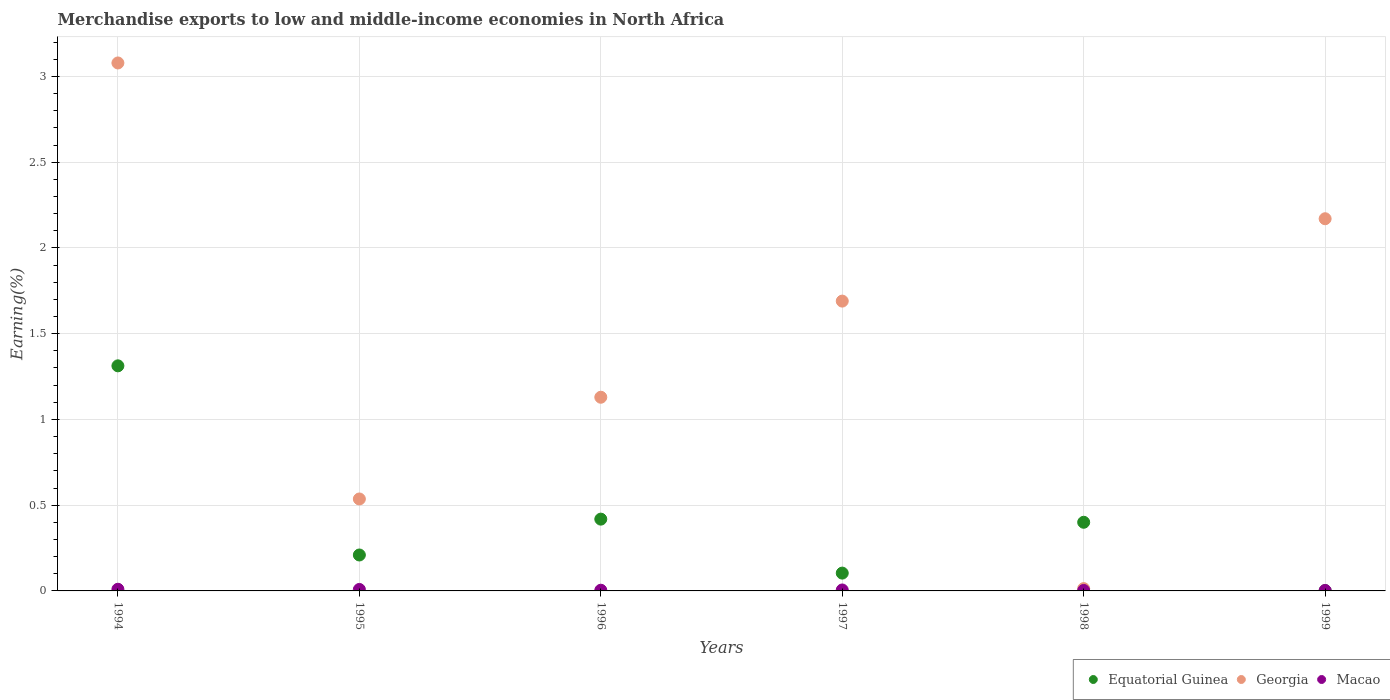How many different coloured dotlines are there?
Offer a terse response. 3. What is the percentage of amount earned from merchandise exports in Equatorial Guinea in 1996?
Offer a very short reply. 0.42. Across all years, what is the maximum percentage of amount earned from merchandise exports in Georgia?
Your response must be concise. 3.08. Across all years, what is the minimum percentage of amount earned from merchandise exports in Equatorial Guinea?
Ensure brevity in your answer.  0. In which year was the percentage of amount earned from merchandise exports in Georgia maximum?
Offer a very short reply. 1994. What is the total percentage of amount earned from merchandise exports in Equatorial Guinea in the graph?
Your answer should be compact. 2.45. What is the difference between the percentage of amount earned from merchandise exports in Equatorial Guinea in 1996 and that in 1998?
Offer a terse response. 0.02. What is the difference between the percentage of amount earned from merchandise exports in Equatorial Guinea in 1997 and the percentage of amount earned from merchandise exports in Georgia in 1995?
Your answer should be very brief. -0.43. What is the average percentage of amount earned from merchandise exports in Georgia per year?
Offer a terse response. 1.44. In the year 1995, what is the difference between the percentage of amount earned from merchandise exports in Macao and percentage of amount earned from merchandise exports in Georgia?
Provide a short and direct response. -0.53. What is the ratio of the percentage of amount earned from merchandise exports in Equatorial Guinea in 1997 to that in 1998?
Make the answer very short. 0.26. What is the difference between the highest and the second highest percentage of amount earned from merchandise exports in Equatorial Guinea?
Give a very brief answer. 0.89. What is the difference between the highest and the lowest percentage of amount earned from merchandise exports in Equatorial Guinea?
Offer a terse response. 1.31. In how many years, is the percentage of amount earned from merchandise exports in Macao greater than the average percentage of amount earned from merchandise exports in Macao taken over all years?
Provide a succinct answer. 2. Is the sum of the percentage of amount earned from merchandise exports in Georgia in 1994 and 1997 greater than the maximum percentage of amount earned from merchandise exports in Equatorial Guinea across all years?
Give a very brief answer. Yes. Is it the case that in every year, the sum of the percentage of amount earned from merchandise exports in Equatorial Guinea and percentage of amount earned from merchandise exports in Georgia  is greater than the percentage of amount earned from merchandise exports in Macao?
Offer a very short reply. Yes. How many dotlines are there?
Ensure brevity in your answer.  3. What is the difference between two consecutive major ticks on the Y-axis?
Your response must be concise. 0.5. Are the values on the major ticks of Y-axis written in scientific E-notation?
Your answer should be compact. No. Does the graph contain grids?
Your response must be concise. Yes. How many legend labels are there?
Give a very brief answer. 3. What is the title of the graph?
Your answer should be very brief. Merchandise exports to low and middle-income economies in North Africa. Does "United States" appear as one of the legend labels in the graph?
Give a very brief answer. No. What is the label or title of the Y-axis?
Your answer should be compact. Earning(%). What is the Earning(%) of Equatorial Guinea in 1994?
Give a very brief answer. 1.31. What is the Earning(%) in Georgia in 1994?
Provide a short and direct response. 3.08. What is the Earning(%) of Macao in 1994?
Your response must be concise. 0.01. What is the Earning(%) in Equatorial Guinea in 1995?
Offer a very short reply. 0.21. What is the Earning(%) in Georgia in 1995?
Offer a very short reply. 0.54. What is the Earning(%) in Macao in 1995?
Provide a short and direct response. 0.01. What is the Earning(%) in Equatorial Guinea in 1996?
Keep it short and to the point. 0.42. What is the Earning(%) in Georgia in 1996?
Offer a terse response. 1.13. What is the Earning(%) in Macao in 1996?
Keep it short and to the point. 0. What is the Earning(%) in Equatorial Guinea in 1997?
Ensure brevity in your answer.  0.1. What is the Earning(%) in Georgia in 1997?
Make the answer very short. 1.69. What is the Earning(%) in Macao in 1997?
Ensure brevity in your answer.  0.01. What is the Earning(%) in Equatorial Guinea in 1998?
Ensure brevity in your answer.  0.4. What is the Earning(%) in Georgia in 1998?
Your response must be concise. 0.01. What is the Earning(%) in Macao in 1998?
Your response must be concise. 0. What is the Earning(%) in Equatorial Guinea in 1999?
Give a very brief answer. 0. What is the Earning(%) in Georgia in 1999?
Your answer should be compact. 2.17. What is the Earning(%) of Macao in 1999?
Your answer should be very brief. 0. Across all years, what is the maximum Earning(%) in Equatorial Guinea?
Give a very brief answer. 1.31. Across all years, what is the maximum Earning(%) of Georgia?
Make the answer very short. 3.08. Across all years, what is the maximum Earning(%) in Macao?
Your response must be concise. 0.01. Across all years, what is the minimum Earning(%) of Equatorial Guinea?
Make the answer very short. 0. Across all years, what is the minimum Earning(%) of Georgia?
Provide a succinct answer. 0.01. Across all years, what is the minimum Earning(%) in Macao?
Offer a terse response. 0. What is the total Earning(%) in Equatorial Guinea in the graph?
Offer a very short reply. 2.45. What is the total Earning(%) of Georgia in the graph?
Ensure brevity in your answer.  8.62. What is the total Earning(%) of Macao in the graph?
Ensure brevity in your answer.  0.03. What is the difference between the Earning(%) of Equatorial Guinea in 1994 and that in 1995?
Your answer should be compact. 1.1. What is the difference between the Earning(%) in Georgia in 1994 and that in 1995?
Offer a terse response. 2.54. What is the difference between the Earning(%) of Macao in 1994 and that in 1995?
Your answer should be compact. 0. What is the difference between the Earning(%) in Equatorial Guinea in 1994 and that in 1996?
Ensure brevity in your answer.  0.89. What is the difference between the Earning(%) in Georgia in 1994 and that in 1996?
Provide a short and direct response. 1.95. What is the difference between the Earning(%) of Macao in 1994 and that in 1996?
Your answer should be very brief. 0.01. What is the difference between the Earning(%) of Equatorial Guinea in 1994 and that in 1997?
Give a very brief answer. 1.21. What is the difference between the Earning(%) of Georgia in 1994 and that in 1997?
Make the answer very short. 1.39. What is the difference between the Earning(%) in Macao in 1994 and that in 1997?
Your answer should be compact. 0. What is the difference between the Earning(%) of Equatorial Guinea in 1994 and that in 1998?
Your response must be concise. 0.91. What is the difference between the Earning(%) of Georgia in 1994 and that in 1998?
Ensure brevity in your answer.  3.07. What is the difference between the Earning(%) in Macao in 1994 and that in 1998?
Offer a terse response. 0.01. What is the difference between the Earning(%) in Equatorial Guinea in 1994 and that in 1999?
Your response must be concise. 1.31. What is the difference between the Earning(%) of Georgia in 1994 and that in 1999?
Your answer should be very brief. 0.91. What is the difference between the Earning(%) in Macao in 1994 and that in 1999?
Give a very brief answer. 0.01. What is the difference between the Earning(%) of Equatorial Guinea in 1995 and that in 1996?
Keep it short and to the point. -0.21. What is the difference between the Earning(%) in Georgia in 1995 and that in 1996?
Ensure brevity in your answer.  -0.59. What is the difference between the Earning(%) of Macao in 1995 and that in 1996?
Your answer should be very brief. 0. What is the difference between the Earning(%) of Equatorial Guinea in 1995 and that in 1997?
Make the answer very short. 0.11. What is the difference between the Earning(%) of Georgia in 1995 and that in 1997?
Offer a terse response. -1.15. What is the difference between the Earning(%) of Macao in 1995 and that in 1997?
Your response must be concise. 0. What is the difference between the Earning(%) of Equatorial Guinea in 1995 and that in 1998?
Keep it short and to the point. -0.19. What is the difference between the Earning(%) in Georgia in 1995 and that in 1998?
Ensure brevity in your answer.  0.52. What is the difference between the Earning(%) in Macao in 1995 and that in 1998?
Offer a terse response. 0.01. What is the difference between the Earning(%) of Equatorial Guinea in 1995 and that in 1999?
Keep it short and to the point. 0.21. What is the difference between the Earning(%) of Georgia in 1995 and that in 1999?
Offer a terse response. -1.63. What is the difference between the Earning(%) of Macao in 1995 and that in 1999?
Offer a terse response. 0.01. What is the difference between the Earning(%) in Equatorial Guinea in 1996 and that in 1997?
Your answer should be compact. 0.31. What is the difference between the Earning(%) of Georgia in 1996 and that in 1997?
Your answer should be compact. -0.56. What is the difference between the Earning(%) of Macao in 1996 and that in 1997?
Your answer should be very brief. -0. What is the difference between the Earning(%) in Equatorial Guinea in 1996 and that in 1998?
Provide a succinct answer. 0.02. What is the difference between the Earning(%) of Georgia in 1996 and that in 1998?
Ensure brevity in your answer.  1.12. What is the difference between the Earning(%) in Macao in 1996 and that in 1998?
Ensure brevity in your answer.  0. What is the difference between the Earning(%) of Equatorial Guinea in 1996 and that in 1999?
Ensure brevity in your answer.  0.42. What is the difference between the Earning(%) of Georgia in 1996 and that in 1999?
Your answer should be very brief. -1.04. What is the difference between the Earning(%) of Macao in 1996 and that in 1999?
Your answer should be compact. 0. What is the difference between the Earning(%) in Equatorial Guinea in 1997 and that in 1998?
Offer a terse response. -0.3. What is the difference between the Earning(%) in Georgia in 1997 and that in 1998?
Your answer should be very brief. 1.68. What is the difference between the Earning(%) in Macao in 1997 and that in 1998?
Ensure brevity in your answer.  0. What is the difference between the Earning(%) of Equatorial Guinea in 1997 and that in 1999?
Provide a succinct answer. 0.1. What is the difference between the Earning(%) of Georgia in 1997 and that in 1999?
Your answer should be compact. -0.48. What is the difference between the Earning(%) of Macao in 1997 and that in 1999?
Make the answer very short. 0. What is the difference between the Earning(%) of Equatorial Guinea in 1998 and that in 1999?
Provide a short and direct response. 0.4. What is the difference between the Earning(%) in Georgia in 1998 and that in 1999?
Keep it short and to the point. -2.16. What is the difference between the Earning(%) in Equatorial Guinea in 1994 and the Earning(%) in Georgia in 1995?
Make the answer very short. 0.78. What is the difference between the Earning(%) in Equatorial Guinea in 1994 and the Earning(%) in Macao in 1995?
Keep it short and to the point. 1.3. What is the difference between the Earning(%) of Georgia in 1994 and the Earning(%) of Macao in 1995?
Your answer should be very brief. 3.07. What is the difference between the Earning(%) in Equatorial Guinea in 1994 and the Earning(%) in Georgia in 1996?
Provide a short and direct response. 0.18. What is the difference between the Earning(%) in Equatorial Guinea in 1994 and the Earning(%) in Macao in 1996?
Offer a very short reply. 1.31. What is the difference between the Earning(%) in Georgia in 1994 and the Earning(%) in Macao in 1996?
Give a very brief answer. 3.07. What is the difference between the Earning(%) of Equatorial Guinea in 1994 and the Earning(%) of Georgia in 1997?
Provide a short and direct response. -0.38. What is the difference between the Earning(%) of Equatorial Guinea in 1994 and the Earning(%) of Macao in 1997?
Offer a terse response. 1.31. What is the difference between the Earning(%) in Georgia in 1994 and the Earning(%) in Macao in 1997?
Provide a short and direct response. 3.07. What is the difference between the Earning(%) in Equatorial Guinea in 1994 and the Earning(%) in Georgia in 1998?
Keep it short and to the point. 1.3. What is the difference between the Earning(%) in Equatorial Guinea in 1994 and the Earning(%) in Macao in 1998?
Give a very brief answer. 1.31. What is the difference between the Earning(%) in Georgia in 1994 and the Earning(%) in Macao in 1998?
Keep it short and to the point. 3.08. What is the difference between the Earning(%) of Equatorial Guinea in 1994 and the Earning(%) of Georgia in 1999?
Provide a short and direct response. -0.86. What is the difference between the Earning(%) in Equatorial Guinea in 1994 and the Earning(%) in Macao in 1999?
Keep it short and to the point. 1.31. What is the difference between the Earning(%) of Georgia in 1994 and the Earning(%) of Macao in 1999?
Give a very brief answer. 3.08. What is the difference between the Earning(%) of Equatorial Guinea in 1995 and the Earning(%) of Georgia in 1996?
Ensure brevity in your answer.  -0.92. What is the difference between the Earning(%) of Equatorial Guinea in 1995 and the Earning(%) of Macao in 1996?
Your response must be concise. 0.21. What is the difference between the Earning(%) in Georgia in 1995 and the Earning(%) in Macao in 1996?
Your answer should be compact. 0.53. What is the difference between the Earning(%) in Equatorial Guinea in 1995 and the Earning(%) in Georgia in 1997?
Make the answer very short. -1.48. What is the difference between the Earning(%) in Equatorial Guinea in 1995 and the Earning(%) in Macao in 1997?
Give a very brief answer. 0.2. What is the difference between the Earning(%) of Georgia in 1995 and the Earning(%) of Macao in 1997?
Offer a terse response. 0.53. What is the difference between the Earning(%) in Equatorial Guinea in 1995 and the Earning(%) in Georgia in 1998?
Ensure brevity in your answer.  0.2. What is the difference between the Earning(%) in Equatorial Guinea in 1995 and the Earning(%) in Macao in 1998?
Your answer should be compact. 0.21. What is the difference between the Earning(%) of Georgia in 1995 and the Earning(%) of Macao in 1998?
Your response must be concise. 0.53. What is the difference between the Earning(%) of Equatorial Guinea in 1995 and the Earning(%) of Georgia in 1999?
Provide a short and direct response. -1.96. What is the difference between the Earning(%) of Equatorial Guinea in 1995 and the Earning(%) of Macao in 1999?
Your answer should be compact. 0.21. What is the difference between the Earning(%) of Georgia in 1995 and the Earning(%) of Macao in 1999?
Offer a very short reply. 0.53. What is the difference between the Earning(%) of Equatorial Guinea in 1996 and the Earning(%) of Georgia in 1997?
Keep it short and to the point. -1.27. What is the difference between the Earning(%) in Equatorial Guinea in 1996 and the Earning(%) in Macao in 1997?
Keep it short and to the point. 0.41. What is the difference between the Earning(%) in Georgia in 1996 and the Earning(%) in Macao in 1997?
Offer a very short reply. 1.12. What is the difference between the Earning(%) in Equatorial Guinea in 1996 and the Earning(%) in Georgia in 1998?
Provide a short and direct response. 0.41. What is the difference between the Earning(%) of Equatorial Guinea in 1996 and the Earning(%) of Macao in 1998?
Ensure brevity in your answer.  0.42. What is the difference between the Earning(%) of Georgia in 1996 and the Earning(%) of Macao in 1998?
Make the answer very short. 1.13. What is the difference between the Earning(%) in Equatorial Guinea in 1996 and the Earning(%) in Georgia in 1999?
Offer a terse response. -1.75. What is the difference between the Earning(%) in Equatorial Guinea in 1996 and the Earning(%) in Macao in 1999?
Offer a very short reply. 0.42. What is the difference between the Earning(%) of Georgia in 1996 and the Earning(%) of Macao in 1999?
Offer a terse response. 1.13. What is the difference between the Earning(%) of Equatorial Guinea in 1997 and the Earning(%) of Georgia in 1998?
Make the answer very short. 0.09. What is the difference between the Earning(%) in Equatorial Guinea in 1997 and the Earning(%) in Macao in 1998?
Your answer should be very brief. 0.1. What is the difference between the Earning(%) in Georgia in 1997 and the Earning(%) in Macao in 1998?
Provide a succinct answer. 1.69. What is the difference between the Earning(%) of Equatorial Guinea in 1997 and the Earning(%) of Georgia in 1999?
Your response must be concise. -2.07. What is the difference between the Earning(%) of Equatorial Guinea in 1997 and the Earning(%) of Macao in 1999?
Your answer should be compact. 0.1. What is the difference between the Earning(%) of Georgia in 1997 and the Earning(%) of Macao in 1999?
Keep it short and to the point. 1.69. What is the difference between the Earning(%) of Equatorial Guinea in 1998 and the Earning(%) of Georgia in 1999?
Your response must be concise. -1.77. What is the difference between the Earning(%) of Equatorial Guinea in 1998 and the Earning(%) of Macao in 1999?
Make the answer very short. 0.4. What is the difference between the Earning(%) of Georgia in 1998 and the Earning(%) of Macao in 1999?
Offer a very short reply. 0.01. What is the average Earning(%) in Equatorial Guinea per year?
Give a very brief answer. 0.41. What is the average Earning(%) of Georgia per year?
Your answer should be very brief. 1.44. What is the average Earning(%) in Macao per year?
Provide a short and direct response. 0.01. In the year 1994, what is the difference between the Earning(%) in Equatorial Guinea and Earning(%) in Georgia?
Your answer should be very brief. -1.77. In the year 1994, what is the difference between the Earning(%) in Equatorial Guinea and Earning(%) in Macao?
Keep it short and to the point. 1.3. In the year 1994, what is the difference between the Earning(%) in Georgia and Earning(%) in Macao?
Your answer should be compact. 3.07. In the year 1995, what is the difference between the Earning(%) of Equatorial Guinea and Earning(%) of Georgia?
Provide a short and direct response. -0.33. In the year 1995, what is the difference between the Earning(%) in Equatorial Guinea and Earning(%) in Macao?
Your answer should be very brief. 0.2. In the year 1995, what is the difference between the Earning(%) in Georgia and Earning(%) in Macao?
Make the answer very short. 0.53. In the year 1996, what is the difference between the Earning(%) in Equatorial Guinea and Earning(%) in Georgia?
Ensure brevity in your answer.  -0.71. In the year 1996, what is the difference between the Earning(%) of Equatorial Guinea and Earning(%) of Macao?
Provide a succinct answer. 0.41. In the year 1996, what is the difference between the Earning(%) in Georgia and Earning(%) in Macao?
Your response must be concise. 1.13. In the year 1997, what is the difference between the Earning(%) in Equatorial Guinea and Earning(%) in Georgia?
Your answer should be compact. -1.59. In the year 1997, what is the difference between the Earning(%) in Equatorial Guinea and Earning(%) in Macao?
Your answer should be compact. 0.1. In the year 1997, what is the difference between the Earning(%) in Georgia and Earning(%) in Macao?
Give a very brief answer. 1.68. In the year 1998, what is the difference between the Earning(%) in Equatorial Guinea and Earning(%) in Georgia?
Your answer should be very brief. 0.39. In the year 1998, what is the difference between the Earning(%) of Equatorial Guinea and Earning(%) of Macao?
Offer a very short reply. 0.4. In the year 1998, what is the difference between the Earning(%) in Georgia and Earning(%) in Macao?
Offer a very short reply. 0.01. In the year 1999, what is the difference between the Earning(%) in Equatorial Guinea and Earning(%) in Georgia?
Offer a very short reply. -2.17. In the year 1999, what is the difference between the Earning(%) of Equatorial Guinea and Earning(%) of Macao?
Keep it short and to the point. -0. In the year 1999, what is the difference between the Earning(%) of Georgia and Earning(%) of Macao?
Your response must be concise. 2.17. What is the ratio of the Earning(%) in Equatorial Guinea in 1994 to that in 1995?
Your response must be concise. 6.26. What is the ratio of the Earning(%) in Georgia in 1994 to that in 1995?
Give a very brief answer. 5.74. What is the ratio of the Earning(%) in Macao in 1994 to that in 1995?
Offer a terse response. 1.13. What is the ratio of the Earning(%) of Equatorial Guinea in 1994 to that in 1996?
Ensure brevity in your answer.  3.14. What is the ratio of the Earning(%) in Georgia in 1994 to that in 1996?
Offer a very short reply. 2.73. What is the ratio of the Earning(%) of Macao in 1994 to that in 1996?
Offer a very short reply. 2.39. What is the ratio of the Earning(%) in Equatorial Guinea in 1994 to that in 1997?
Offer a terse response. 12.63. What is the ratio of the Earning(%) in Georgia in 1994 to that in 1997?
Provide a succinct answer. 1.82. What is the ratio of the Earning(%) of Macao in 1994 to that in 1997?
Provide a short and direct response. 1.76. What is the ratio of the Earning(%) in Equatorial Guinea in 1994 to that in 1998?
Provide a short and direct response. 3.28. What is the ratio of the Earning(%) in Georgia in 1994 to that in 1998?
Offer a terse response. 228.97. What is the ratio of the Earning(%) in Macao in 1994 to that in 1998?
Your answer should be very brief. 3.64. What is the ratio of the Earning(%) in Equatorial Guinea in 1994 to that in 1999?
Your response must be concise. 788.37. What is the ratio of the Earning(%) of Georgia in 1994 to that in 1999?
Provide a short and direct response. 1.42. What is the ratio of the Earning(%) in Macao in 1994 to that in 1999?
Your response must be concise. 3.77. What is the ratio of the Earning(%) of Equatorial Guinea in 1995 to that in 1996?
Make the answer very short. 0.5. What is the ratio of the Earning(%) in Georgia in 1995 to that in 1996?
Your answer should be very brief. 0.47. What is the ratio of the Earning(%) of Macao in 1995 to that in 1996?
Provide a succinct answer. 2.11. What is the ratio of the Earning(%) of Equatorial Guinea in 1995 to that in 1997?
Make the answer very short. 2.02. What is the ratio of the Earning(%) in Georgia in 1995 to that in 1997?
Keep it short and to the point. 0.32. What is the ratio of the Earning(%) of Macao in 1995 to that in 1997?
Provide a succinct answer. 1.55. What is the ratio of the Earning(%) of Equatorial Guinea in 1995 to that in 1998?
Your answer should be very brief. 0.52. What is the ratio of the Earning(%) of Georgia in 1995 to that in 1998?
Your response must be concise. 39.88. What is the ratio of the Earning(%) in Macao in 1995 to that in 1998?
Your response must be concise. 3.21. What is the ratio of the Earning(%) of Equatorial Guinea in 1995 to that in 1999?
Provide a short and direct response. 125.85. What is the ratio of the Earning(%) in Georgia in 1995 to that in 1999?
Make the answer very short. 0.25. What is the ratio of the Earning(%) of Macao in 1995 to that in 1999?
Provide a short and direct response. 3.33. What is the ratio of the Earning(%) of Equatorial Guinea in 1996 to that in 1997?
Offer a very short reply. 4.03. What is the ratio of the Earning(%) of Georgia in 1996 to that in 1997?
Your answer should be very brief. 0.67. What is the ratio of the Earning(%) of Macao in 1996 to that in 1997?
Provide a short and direct response. 0.74. What is the ratio of the Earning(%) of Equatorial Guinea in 1996 to that in 1998?
Offer a terse response. 1.05. What is the ratio of the Earning(%) of Georgia in 1996 to that in 1998?
Your response must be concise. 83.99. What is the ratio of the Earning(%) of Macao in 1996 to that in 1998?
Keep it short and to the point. 1.52. What is the ratio of the Earning(%) in Equatorial Guinea in 1996 to that in 1999?
Provide a succinct answer. 251.46. What is the ratio of the Earning(%) of Georgia in 1996 to that in 1999?
Provide a succinct answer. 0.52. What is the ratio of the Earning(%) in Macao in 1996 to that in 1999?
Make the answer very short. 1.58. What is the ratio of the Earning(%) in Equatorial Guinea in 1997 to that in 1998?
Your answer should be compact. 0.26. What is the ratio of the Earning(%) of Georgia in 1997 to that in 1998?
Provide a succinct answer. 125.69. What is the ratio of the Earning(%) in Macao in 1997 to that in 1998?
Offer a very short reply. 2.07. What is the ratio of the Earning(%) in Equatorial Guinea in 1997 to that in 1999?
Offer a very short reply. 62.4. What is the ratio of the Earning(%) in Georgia in 1997 to that in 1999?
Offer a very short reply. 0.78. What is the ratio of the Earning(%) in Macao in 1997 to that in 1999?
Your answer should be compact. 2.14. What is the ratio of the Earning(%) of Equatorial Guinea in 1998 to that in 1999?
Provide a succinct answer. 240.44. What is the ratio of the Earning(%) of Georgia in 1998 to that in 1999?
Your response must be concise. 0.01. What is the ratio of the Earning(%) of Macao in 1998 to that in 1999?
Make the answer very short. 1.04. What is the difference between the highest and the second highest Earning(%) in Equatorial Guinea?
Keep it short and to the point. 0.89. What is the difference between the highest and the second highest Earning(%) of Georgia?
Offer a very short reply. 0.91. What is the difference between the highest and the second highest Earning(%) in Macao?
Your answer should be compact. 0. What is the difference between the highest and the lowest Earning(%) in Equatorial Guinea?
Offer a very short reply. 1.31. What is the difference between the highest and the lowest Earning(%) in Georgia?
Your answer should be very brief. 3.07. What is the difference between the highest and the lowest Earning(%) of Macao?
Your answer should be very brief. 0.01. 